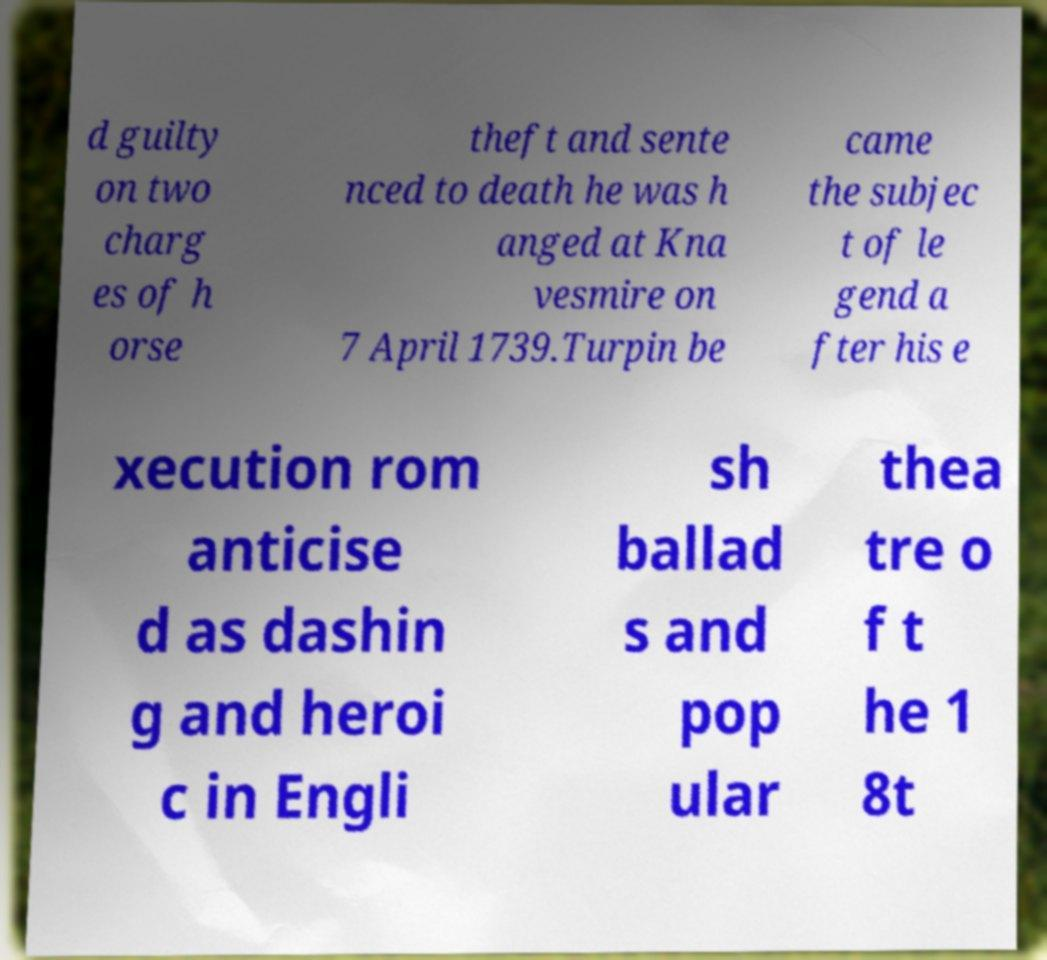Please identify and transcribe the text found in this image. d guilty on two charg es of h orse theft and sente nced to death he was h anged at Kna vesmire on 7 April 1739.Turpin be came the subjec t of le gend a fter his e xecution rom anticise d as dashin g and heroi c in Engli sh ballad s and pop ular thea tre o f t he 1 8t 